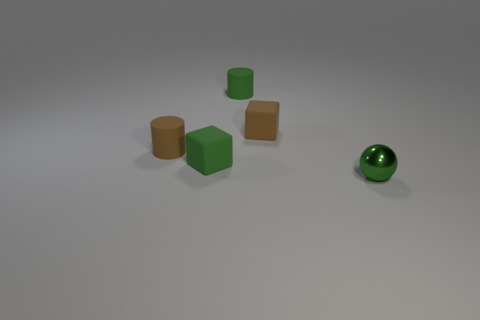The small green object that is both in front of the green matte cylinder and to the right of the green cube is made of what material?
Provide a succinct answer. Metal. Is the number of small green spheres that are in front of the green shiny ball less than the number of tiny objects in front of the brown rubber cube?
Your response must be concise. Yes. Is the material of the tiny green cylinder the same as the small object that is to the left of the green block?
Your response must be concise. Yes. Is there anything else that has the same material as the small green ball?
Ensure brevity in your answer.  No. Is the material of the small cube that is on the left side of the brown block the same as the small cube that is behind the green cube?
Offer a very short reply. Yes. There is a small block in front of the brown rubber cube that is behind the matte cylinder that is left of the green matte cylinder; what color is it?
Your answer should be very brief. Green. How many other things are the same shape as the metallic thing?
Ensure brevity in your answer.  0. What number of objects are rubber objects or small brown objects to the left of the tiny green cylinder?
Your answer should be compact. 4. Is there a blue sphere that has the same size as the green rubber cylinder?
Make the answer very short. No. Does the brown cube have the same material as the ball?
Offer a very short reply. No. 